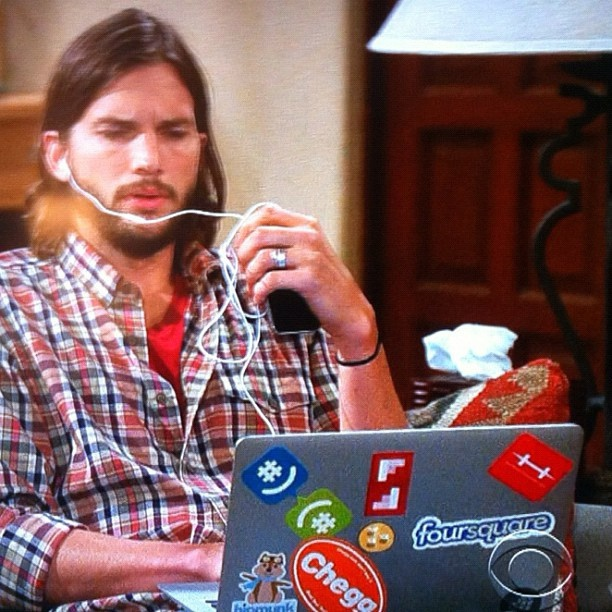Describe the objects in this image and their specific colors. I can see people in brown, lavender, maroon, and lightpink tones, laptop in brown, gray, darkblue, navy, and black tones, and cell phone in brown, black, gray, and maroon tones in this image. 